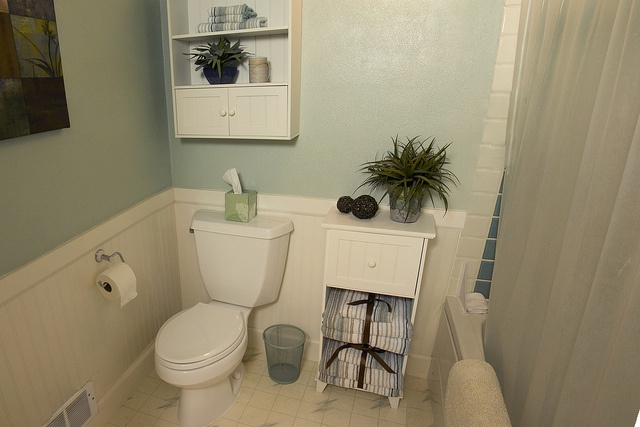Describe the objects in this image and their specific colors. I can see toilet in gray and tan tones, potted plant in gray, black, darkgray, and darkgreen tones, and potted plant in gray, black, darkgreen, and darkgray tones in this image. 